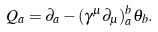Convert formula to latex. <formula><loc_0><loc_0><loc_500><loc_500>Q _ { a } = \partial _ { a } - ( \gamma ^ { \mu } \partial _ { \mu } ) ^ { b } _ { a } \theta _ { b } .</formula> 